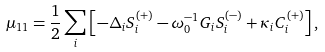Convert formula to latex. <formula><loc_0><loc_0><loc_500><loc_500>\mu _ { 1 1 } = \frac { 1 } { 2 } \sum _ { i } \left [ - \Delta _ { i } S _ { i } ^ { ( + ) } - \omega _ { 0 } ^ { - 1 } G _ { i } S _ { i } ^ { ( - ) } + \kappa _ { i } C _ { i } ^ { ( + ) } \right ] ,</formula> 